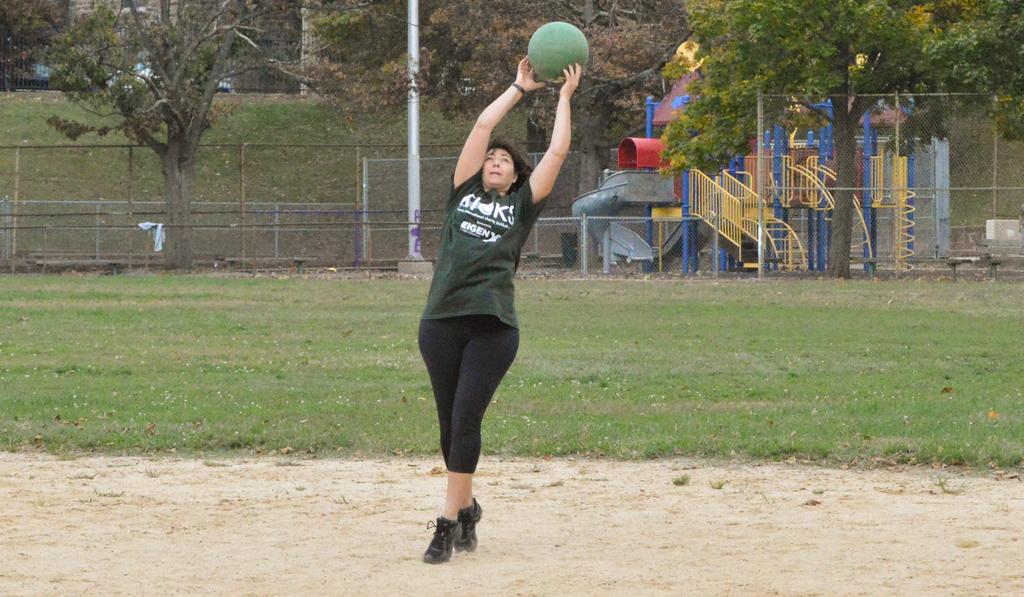Who is present in the image? There is a woman in the image. What is the woman holding in the image? The woman is holding a ball. Where is the woman standing in the image? The woman is standing on the ground. What can be seen in the background of the image? There are trees visible at the top of the image. What structures are present in the image? There is a fence and a staircase in the image. What type of cactus can be seen growing near the staircase in the image? There is no cactus present in the image; it features a woman holding a ball, trees in the background, a fence, and a staircase. 